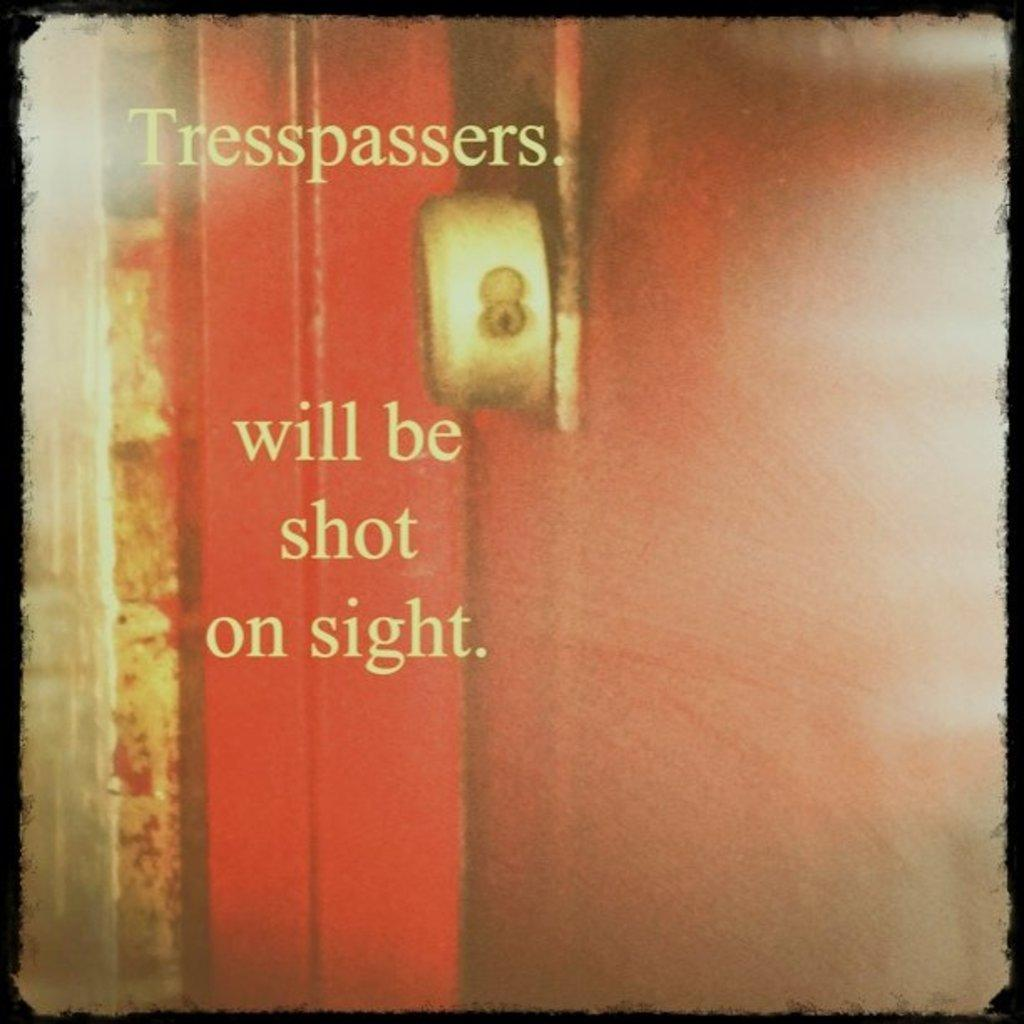<image>
Render a clear and concise summary of the photo. A photo of a closed red door that says Tresspassers. will be shot on sight. 